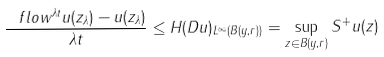Convert formula to latex. <formula><loc_0><loc_0><loc_500><loc_500>\frac { \ f l o w ^ { \lambda t } u ( z _ { \lambda } ) - u ( z _ { \lambda } ) } { \lambda t } \leq \| H ( D u ) \| _ { L ^ { \infty } ( B ( y , r ) ) } = \sup _ { z \in B ( y , r ) } S ^ { + } u ( z )</formula> 